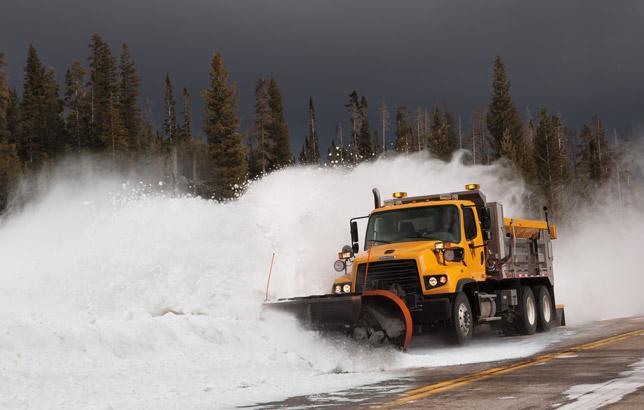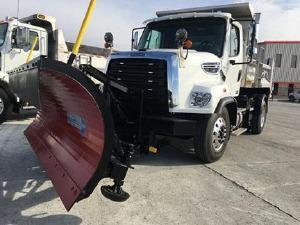The first image is the image on the left, the second image is the image on the right. For the images shown, is this caption "All plows shown feature the same color, and in the right image, a truck the same color as its plow is aimed rightward at an angle." true? Answer yes or no. No. The first image is the image on the left, the second image is the image on the right. Evaluate the accuracy of this statement regarding the images: "One snow plow is plowing snow.". Is it true? Answer yes or no. Yes. 